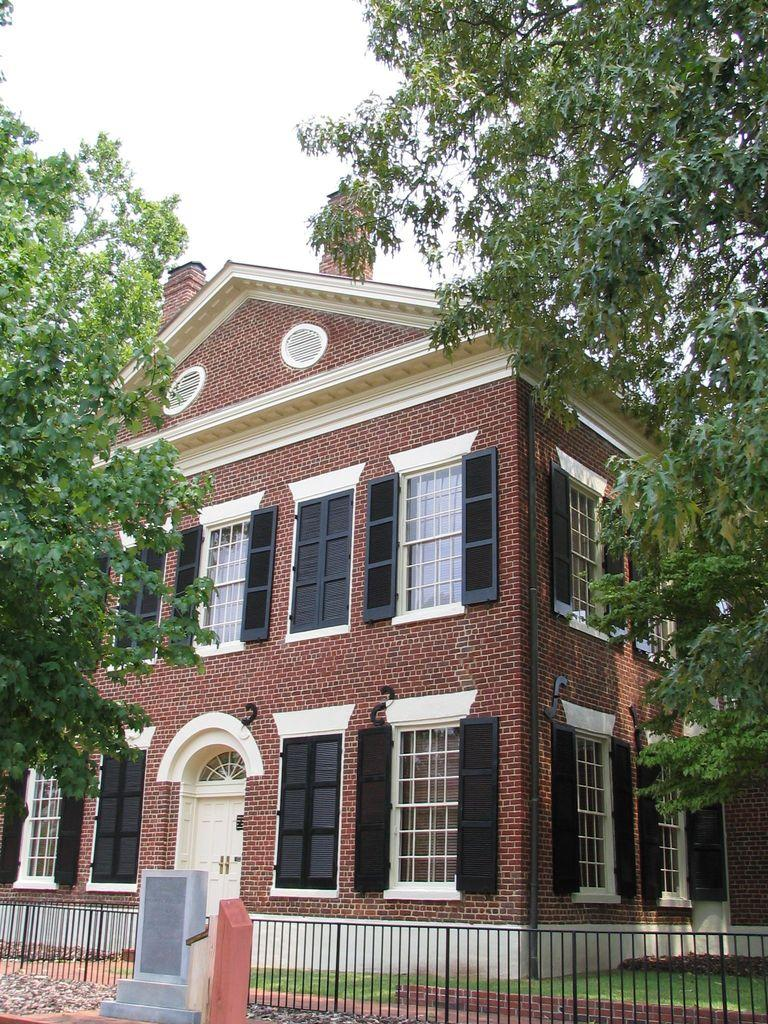What type of structure is present in the image? There is a building in the image. What feature of the building is mentioned in the facts? The building has multiple windows. What color are the doors in the image? There are white-colored doors in the image. What can be seen in the background of the image? There are trees visible in the image. What statement does the daughter make about the building in the image? There is no daughter present in the image, and therefore no statement can be attributed to her. 